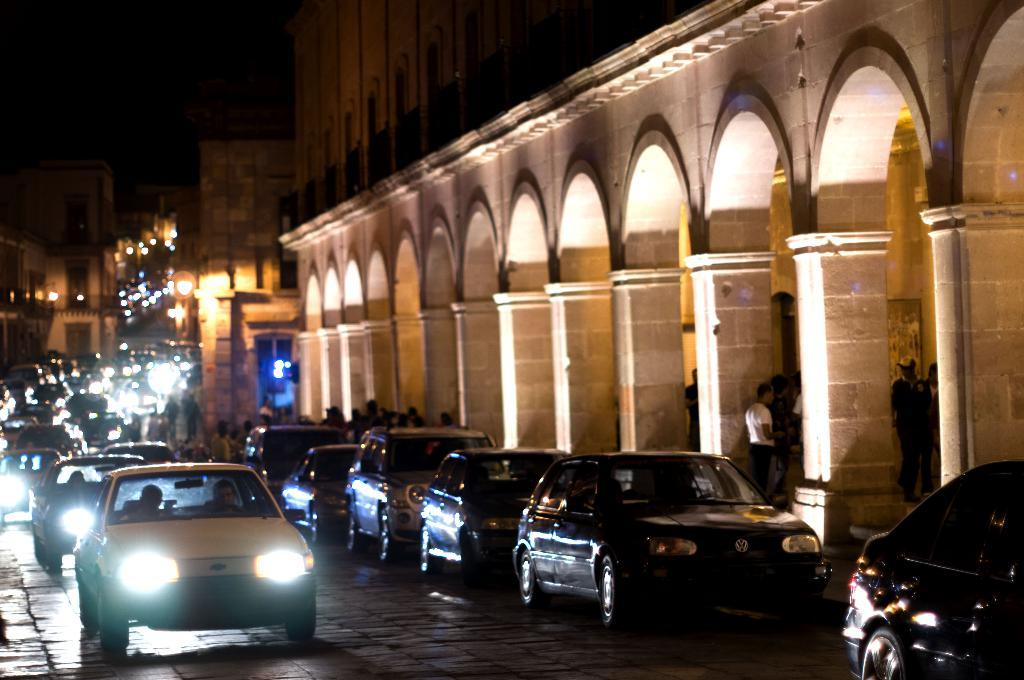What type of vehicles can be seen on the road in the image? There are cars on the road in the image. What can be seen in the distance behind the cars? There are buildings in the background of the image. Where are the people located in the image? The people are standing under a building on the right side of the image. What type of cap is the pie wearing in the image? There is no cap or pie present in the image. 